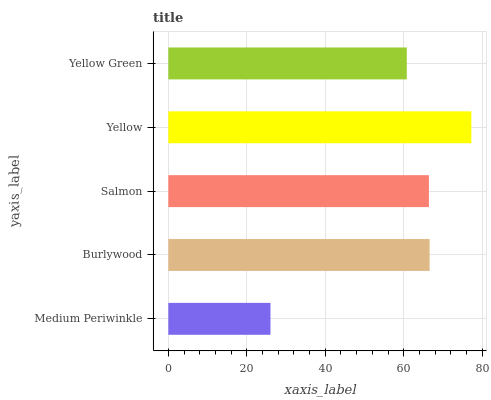Is Medium Periwinkle the minimum?
Answer yes or no. Yes. Is Yellow the maximum?
Answer yes or no. Yes. Is Burlywood the minimum?
Answer yes or no. No. Is Burlywood the maximum?
Answer yes or no. No. Is Burlywood greater than Medium Periwinkle?
Answer yes or no. Yes. Is Medium Periwinkle less than Burlywood?
Answer yes or no. Yes. Is Medium Periwinkle greater than Burlywood?
Answer yes or no. No. Is Burlywood less than Medium Periwinkle?
Answer yes or no. No. Is Salmon the high median?
Answer yes or no. Yes. Is Salmon the low median?
Answer yes or no. Yes. Is Yellow the high median?
Answer yes or no. No. Is Medium Periwinkle the low median?
Answer yes or no. No. 